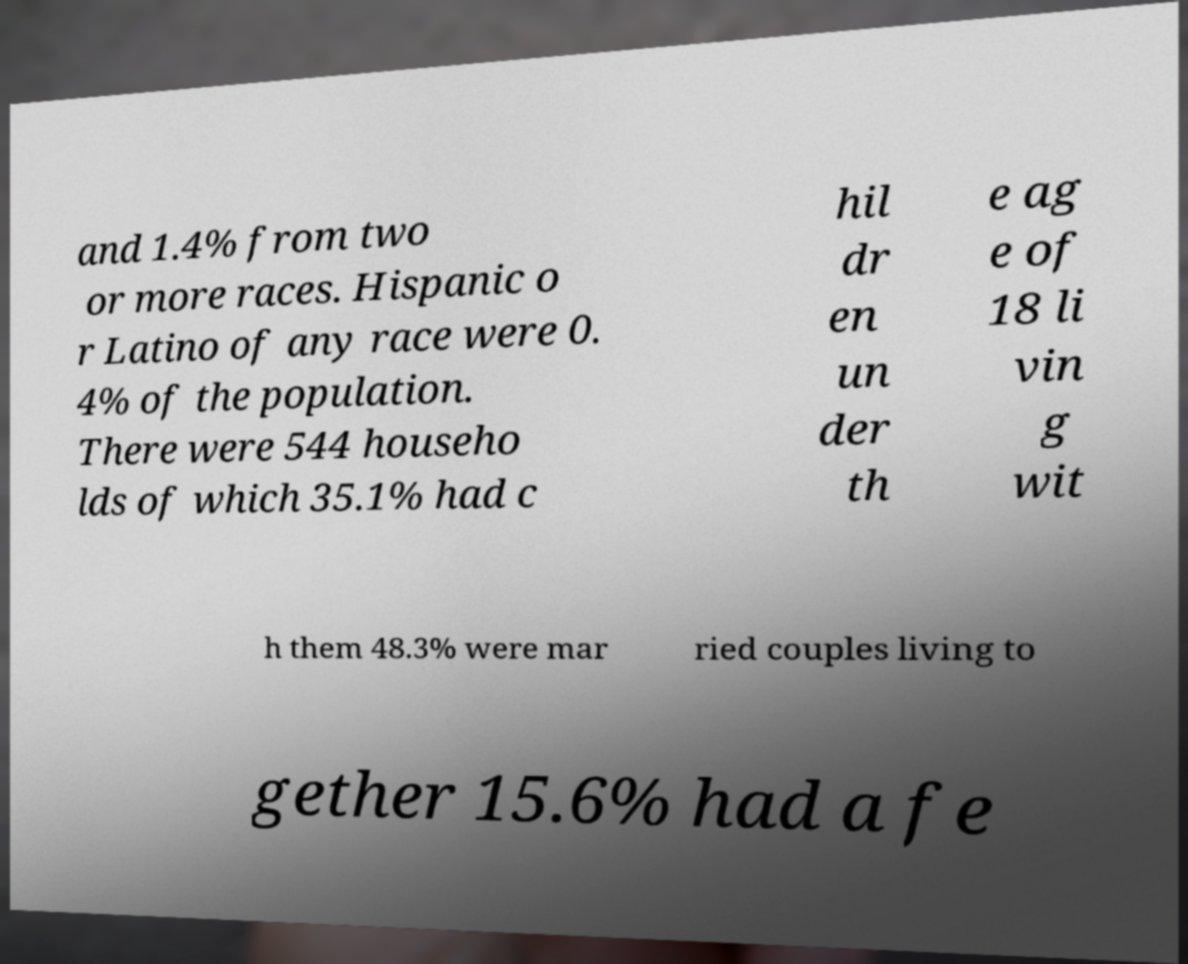Please identify and transcribe the text found in this image. and 1.4% from two or more races. Hispanic o r Latino of any race were 0. 4% of the population. There were 544 househo lds of which 35.1% had c hil dr en un der th e ag e of 18 li vin g wit h them 48.3% were mar ried couples living to gether 15.6% had a fe 